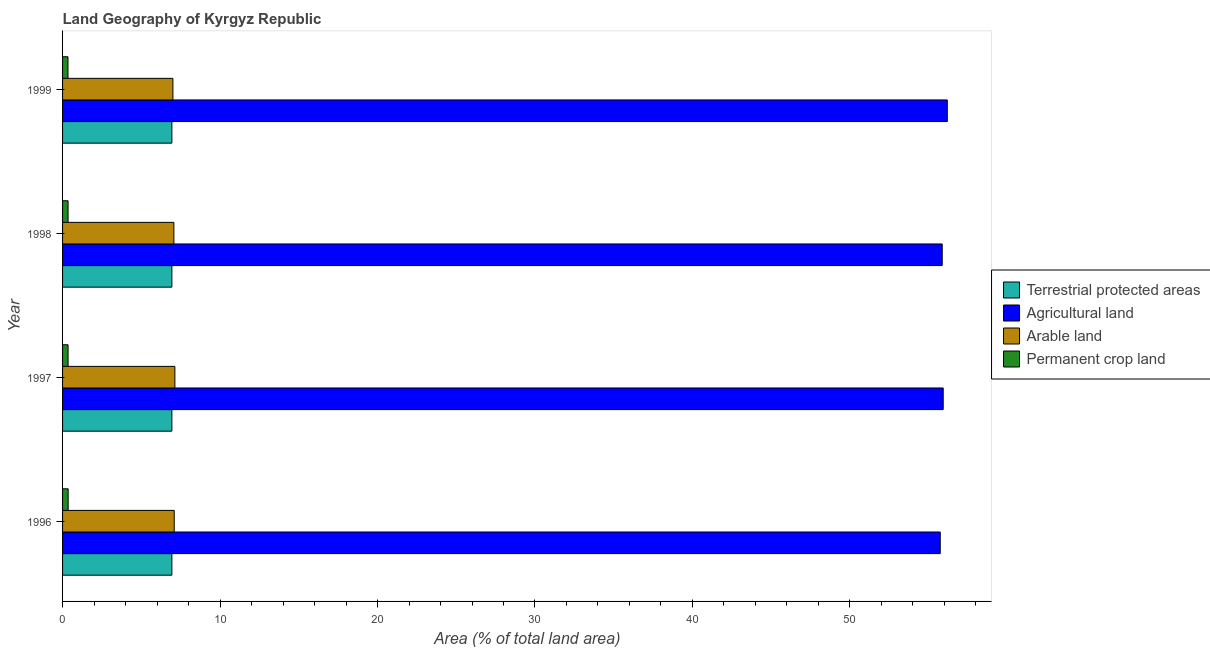Are the number of bars per tick equal to the number of legend labels?
Ensure brevity in your answer.  Yes. How many bars are there on the 4th tick from the bottom?
Give a very brief answer. 4. What is the label of the 1st group of bars from the top?
Your answer should be compact. 1999. What is the percentage of area under arable land in 1999?
Your answer should be compact. 7.01. Across all years, what is the maximum percentage of area under arable land?
Give a very brief answer. 7.13. Across all years, what is the minimum percentage of area under agricultural land?
Provide a short and direct response. 55.74. In which year was the percentage of area under agricultural land minimum?
Make the answer very short. 1996. What is the total percentage of area under permanent crop land in the graph?
Offer a very short reply. 1.4. What is the difference between the percentage of area under agricultural land in 1996 and that in 1997?
Offer a terse response. -0.19. What is the difference between the percentage of area under agricultural land in 1999 and the percentage of area under permanent crop land in 1996?
Your answer should be very brief. 55.83. What is the average percentage of area under permanent crop land per year?
Give a very brief answer. 0.35. In the year 1996, what is the difference between the percentage of area under agricultural land and percentage of area under permanent crop land?
Make the answer very short. 55.38. Is the percentage of land under terrestrial protection in 1996 less than that in 1998?
Give a very brief answer. No. What is the difference between the highest and the second highest percentage of area under arable land?
Provide a short and direct response. 0.04. What is the difference between the highest and the lowest percentage of area under agricultural land?
Offer a very short reply. 0.45. In how many years, is the percentage of area under permanent crop land greater than the average percentage of area under permanent crop land taken over all years?
Keep it short and to the point. 1. Is the sum of the percentage of area under permanent crop land in 1996 and 1997 greater than the maximum percentage of land under terrestrial protection across all years?
Provide a short and direct response. No. What does the 1st bar from the top in 1996 represents?
Your answer should be very brief. Permanent crop land. What does the 2nd bar from the bottom in 1997 represents?
Make the answer very short. Agricultural land. Is it the case that in every year, the sum of the percentage of land under terrestrial protection and percentage of area under agricultural land is greater than the percentage of area under arable land?
Provide a succinct answer. Yes. How many bars are there?
Your answer should be compact. 16. Are all the bars in the graph horizontal?
Provide a short and direct response. Yes. What is the difference between two consecutive major ticks on the X-axis?
Keep it short and to the point. 10. Are the values on the major ticks of X-axis written in scientific E-notation?
Keep it short and to the point. No. Does the graph contain any zero values?
Ensure brevity in your answer.  No. Where does the legend appear in the graph?
Make the answer very short. Center right. How are the legend labels stacked?
Offer a very short reply. Vertical. What is the title of the graph?
Give a very brief answer. Land Geography of Kyrgyz Republic. Does "Secondary schools" appear as one of the legend labels in the graph?
Give a very brief answer. No. What is the label or title of the X-axis?
Keep it short and to the point. Area (% of total land area). What is the label or title of the Y-axis?
Make the answer very short. Year. What is the Area (% of total land area) of Terrestrial protected areas in 1996?
Your answer should be very brief. 6.94. What is the Area (% of total land area) in Agricultural land in 1996?
Your response must be concise. 55.74. What is the Area (% of total land area) of Arable land in 1996?
Offer a terse response. 7.09. What is the Area (% of total land area) in Permanent crop land in 1996?
Your answer should be very brief. 0.35. What is the Area (% of total land area) in Terrestrial protected areas in 1997?
Offer a terse response. 6.94. What is the Area (% of total land area) of Agricultural land in 1997?
Your response must be concise. 55.92. What is the Area (% of total land area) in Arable land in 1997?
Offer a terse response. 7.13. What is the Area (% of total land area) in Permanent crop land in 1997?
Your answer should be compact. 0.35. What is the Area (% of total land area) of Terrestrial protected areas in 1998?
Offer a terse response. 6.94. What is the Area (% of total land area) in Agricultural land in 1998?
Your answer should be very brief. 55.86. What is the Area (% of total land area) in Arable land in 1998?
Your answer should be compact. 7.07. What is the Area (% of total land area) in Permanent crop land in 1998?
Your answer should be very brief. 0.35. What is the Area (% of total land area) in Terrestrial protected areas in 1999?
Provide a short and direct response. 6.94. What is the Area (% of total land area) of Agricultural land in 1999?
Keep it short and to the point. 56.18. What is the Area (% of total land area) in Arable land in 1999?
Ensure brevity in your answer.  7.01. What is the Area (% of total land area) in Permanent crop land in 1999?
Offer a very short reply. 0.34. Across all years, what is the maximum Area (% of total land area) of Terrestrial protected areas?
Provide a short and direct response. 6.94. Across all years, what is the maximum Area (% of total land area) in Agricultural land?
Provide a succinct answer. 56.18. Across all years, what is the maximum Area (% of total land area) in Arable land?
Offer a terse response. 7.13. Across all years, what is the maximum Area (% of total land area) of Permanent crop land?
Offer a very short reply. 0.35. Across all years, what is the minimum Area (% of total land area) in Terrestrial protected areas?
Offer a very short reply. 6.94. Across all years, what is the minimum Area (% of total land area) in Agricultural land?
Make the answer very short. 55.74. Across all years, what is the minimum Area (% of total land area) of Arable land?
Keep it short and to the point. 7.01. Across all years, what is the minimum Area (% of total land area) of Permanent crop land?
Give a very brief answer. 0.34. What is the total Area (% of total land area) in Terrestrial protected areas in the graph?
Your answer should be compact. 27.77. What is the total Area (% of total land area) of Agricultural land in the graph?
Provide a succinct answer. 223.7. What is the total Area (% of total land area) in Arable land in the graph?
Provide a succinct answer. 28.3. What is the total Area (% of total land area) of Permanent crop land in the graph?
Ensure brevity in your answer.  1.4. What is the difference between the Area (% of total land area) of Terrestrial protected areas in 1996 and that in 1997?
Offer a terse response. 0. What is the difference between the Area (% of total land area) in Agricultural land in 1996 and that in 1997?
Provide a succinct answer. -0.19. What is the difference between the Area (% of total land area) in Arable land in 1996 and that in 1997?
Provide a short and direct response. -0.04. What is the difference between the Area (% of total land area) of Permanent crop land in 1996 and that in 1997?
Keep it short and to the point. 0.01. What is the difference between the Area (% of total land area) in Agricultural land in 1996 and that in 1998?
Provide a succinct answer. -0.13. What is the difference between the Area (% of total land area) of Arable land in 1996 and that in 1998?
Your answer should be compact. 0.02. What is the difference between the Area (% of total land area) in Permanent crop land in 1996 and that in 1998?
Give a very brief answer. 0.01. What is the difference between the Area (% of total land area) in Terrestrial protected areas in 1996 and that in 1999?
Your answer should be compact. 0. What is the difference between the Area (% of total land area) in Agricultural land in 1996 and that in 1999?
Make the answer very short. -0.45. What is the difference between the Area (% of total land area) in Arable land in 1996 and that in 1999?
Offer a very short reply. 0.08. What is the difference between the Area (% of total land area) in Permanent crop land in 1996 and that in 1999?
Offer a very short reply. 0.01. What is the difference between the Area (% of total land area) in Agricultural land in 1997 and that in 1998?
Offer a very short reply. 0.06. What is the difference between the Area (% of total land area) in Arable land in 1997 and that in 1998?
Keep it short and to the point. 0.06. What is the difference between the Area (% of total land area) of Permanent crop land in 1997 and that in 1998?
Provide a succinct answer. 0. What is the difference between the Area (% of total land area) in Terrestrial protected areas in 1997 and that in 1999?
Provide a short and direct response. 0. What is the difference between the Area (% of total land area) of Agricultural land in 1997 and that in 1999?
Your response must be concise. -0.26. What is the difference between the Area (% of total land area) in Arable land in 1997 and that in 1999?
Ensure brevity in your answer.  0.13. What is the difference between the Area (% of total land area) in Permanent crop land in 1997 and that in 1999?
Your answer should be very brief. 0.01. What is the difference between the Area (% of total land area) of Agricultural land in 1998 and that in 1999?
Your response must be concise. -0.32. What is the difference between the Area (% of total land area) of Arable land in 1998 and that in 1999?
Provide a succinct answer. 0.06. What is the difference between the Area (% of total land area) in Permanent crop land in 1998 and that in 1999?
Keep it short and to the point. 0.01. What is the difference between the Area (% of total land area) in Terrestrial protected areas in 1996 and the Area (% of total land area) in Agricultural land in 1997?
Keep it short and to the point. -48.98. What is the difference between the Area (% of total land area) of Terrestrial protected areas in 1996 and the Area (% of total land area) of Arable land in 1997?
Your response must be concise. -0.19. What is the difference between the Area (% of total land area) of Terrestrial protected areas in 1996 and the Area (% of total land area) of Permanent crop land in 1997?
Give a very brief answer. 6.59. What is the difference between the Area (% of total land area) in Agricultural land in 1996 and the Area (% of total land area) in Arable land in 1997?
Provide a succinct answer. 48.6. What is the difference between the Area (% of total land area) of Agricultural land in 1996 and the Area (% of total land area) of Permanent crop land in 1997?
Your answer should be compact. 55.39. What is the difference between the Area (% of total land area) in Arable land in 1996 and the Area (% of total land area) in Permanent crop land in 1997?
Offer a terse response. 6.74. What is the difference between the Area (% of total land area) of Terrestrial protected areas in 1996 and the Area (% of total land area) of Agricultural land in 1998?
Offer a very short reply. -48.92. What is the difference between the Area (% of total land area) in Terrestrial protected areas in 1996 and the Area (% of total land area) in Arable land in 1998?
Provide a short and direct response. -0.13. What is the difference between the Area (% of total land area) of Terrestrial protected areas in 1996 and the Area (% of total land area) of Permanent crop land in 1998?
Your response must be concise. 6.59. What is the difference between the Area (% of total land area) in Agricultural land in 1996 and the Area (% of total land area) in Arable land in 1998?
Offer a very short reply. 48.67. What is the difference between the Area (% of total land area) in Agricultural land in 1996 and the Area (% of total land area) in Permanent crop land in 1998?
Keep it short and to the point. 55.39. What is the difference between the Area (% of total land area) in Arable land in 1996 and the Area (% of total land area) in Permanent crop land in 1998?
Your response must be concise. 6.74. What is the difference between the Area (% of total land area) in Terrestrial protected areas in 1996 and the Area (% of total land area) in Agricultural land in 1999?
Make the answer very short. -49.24. What is the difference between the Area (% of total land area) of Terrestrial protected areas in 1996 and the Area (% of total land area) of Arable land in 1999?
Your response must be concise. -0.07. What is the difference between the Area (% of total land area) of Terrestrial protected areas in 1996 and the Area (% of total land area) of Permanent crop land in 1999?
Provide a succinct answer. 6.6. What is the difference between the Area (% of total land area) of Agricultural land in 1996 and the Area (% of total land area) of Arable land in 1999?
Offer a very short reply. 48.73. What is the difference between the Area (% of total land area) in Agricultural land in 1996 and the Area (% of total land area) in Permanent crop land in 1999?
Your answer should be very brief. 55.39. What is the difference between the Area (% of total land area) of Arable land in 1996 and the Area (% of total land area) of Permanent crop land in 1999?
Your answer should be very brief. 6.75. What is the difference between the Area (% of total land area) of Terrestrial protected areas in 1997 and the Area (% of total land area) of Agricultural land in 1998?
Provide a short and direct response. -48.92. What is the difference between the Area (% of total land area) of Terrestrial protected areas in 1997 and the Area (% of total land area) of Arable land in 1998?
Provide a succinct answer. -0.13. What is the difference between the Area (% of total land area) in Terrestrial protected areas in 1997 and the Area (% of total land area) in Permanent crop land in 1998?
Ensure brevity in your answer.  6.59. What is the difference between the Area (% of total land area) in Agricultural land in 1997 and the Area (% of total land area) in Arable land in 1998?
Give a very brief answer. 48.85. What is the difference between the Area (% of total land area) of Agricultural land in 1997 and the Area (% of total land area) of Permanent crop land in 1998?
Provide a short and direct response. 55.57. What is the difference between the Area (% of total land area) of Arable land in 1997 and the Area (% of total land area) of Permanent crop land in 1998?
Your answer should be very brief. 6.78. What is the difference between the Area (% of total land area) of Terrestrial protected areas in 1997 and the Area (% of total land area) of Agricultural land in 1999?
Provide a short and direct response. -49.24. What is the difference between the Area (% of total land area) of Terrestrial protected areas in 1997 and the Area (% of total land area) of Arable land in 1999?
Offer a terse response. -0.07. What is the difference between the Area (% of total land area) of Terrestrial protected areas in 1997 and the Area (% of total land area) of Permanent crop land in 1999?
Your answer should be compact. 6.6. What is the difference between the Area (% of total land area) of Agricultural land in 1997 and the Area (% of total land area) of Arable land in 1999?
Your answer should be compact. 48.92. What is the difference between the Area (% of total land area) of Agricultural land in 1997 and the Area (% of total land area) of Permanent crop land in 1999?
Make the answer very short. 55.58. What is the difference between the Area (% of total land area) of Arable land in 1997 and the Area (% of total land area) of Permanent crop land in 1999?
Make the answer very short. 6.79. What is the difference between the Area (% of total land area) in Terrestrial protected areas in 1998 and the Area (% of total land area) in Agricultural land in 1999?
Provide a short and direct response. -49.24. What is the difference between the Area (% of total land area) of Terrestrial protected areas in 1998 and the Area (% of total land area) of Arable land in 1999?
Your response must be concise. -0.07. What is the difference between the Area (% of total land area) in Terrestrial protected areas in 1998 and the Area (% of total land area) in Permanent crop land in 1999?
Your response must be concise. 6.6. What is the difference between the Area (% of total land area) of Agricultural land in 1998 and the Area (% of total land area) of Arable land in 1999?
Your response must be concise. 48.85. What is the difference between the Area (% of total land area) in Agricultural land in 1998 and the Area (% of total land area) in Permanent crop land in 1999?
Offer a very short reply. 55.52. What is the difference between the Area (% of total land area) in Arable land in 1998 and the Area (% of total land area) in Permanent crop land in 1999?
Provide a succinct answer. 6.73. What is the average Area (% of total land area) of Terrestrial protected areas per year?
Provide a short and direct response. 6.94. What is the average Area (% of total land area) of Agricultural land per year?
Make the answer very short. 55.93. What is the average Area (% of total land area) of Arable land per year?
Ensure brevity in your answer.  7.08. What is the average Area (% of total land area) of Permanent crop land per year?
Make the answer very short. 0.35. In the year 1996, what is the difference between the Area (% of total land area) of Terrestrial protected areas and Area (% of total land area) of Agricultural land?
Your response must be concise. -48.79. In the year 1996, what is the difference between the Area (% of total land area) in Terrestrial protected areas and Area (% of total land area) in Arable land?
Keep it short and to the point. -0.15. In the year 1996, what is the difference between the Area (% of total land area) of Terrestrial protected areas and Area (% of total land area) of Permanent crop land?
Your answer should be compact. 6.59. In the year 1996, what is the difference between the Area (% of total land area) in Agricultural land and Area (% of total land area) in Arable land?
Offer a terse response. 48.64. In the year 1996, what is the difference between the Area (% of total land area) of Agricultural land and Area (% of total land area) of Permanent crop land?
Your answer should be compact. 55.38. In the year 1996, what is the difference between the Area (% of total land area) of Arable land and Area (% of total land area) of Permanent crop land?
Give a very brief answer. 6.74. In the year 1997, what is the difference between the Area (% of total land area) in Terrestrial protected areas and Area (% of total land area) in Agricultural land?
Your response must be concise. -48.98. In the year 1997, what is the difference between the Area (% of total land area) of Terrestrial protected areas and Area (% of total land area) of Arable land?
Provide a succinct answer. -0.19. In the year 1997, what is the difference between the Area (% of total land area) of Terrestrial protected areas and Area (% of total land area) of Permanent crop land?
Provide a short and direct response. 6.59. In the year 1997, what is the difference between the Area (% of total land area) in Agricultural land and Area (% of total land area) in Arable land?
Your answer should be compact. 48.79. In the year 1997, what is the difference between the Area (% of total land area) of Agricultural land and Area (% of total land area) of Permanent crop land?
Your answer should be compact. 55.57. In the year 1997, what is the difference between the Area (% of total land area) of Arable land and Area (% of total land area) of Permanent crop land?
Keep it short and to the point. 6.78. In the year 1998, what is the difference between the Area (% of total land area) in Terrestrial protected areas and Area (% of total land area) in Agricultural land?
Provide a succinct answer. -48.92. In the year 1998, what is the difference between the Area (% of total land area) in Terrestrial protected areas and Area (% of total land area) in Arable land?
Offer a terse response. -0.13. In the year 1998, what is the difference between the Area (% of total land area) in Terrestrial protected areas and Area (% of total land area) in Permanent crop land?
Make the answer very short. 6.59. In the year 1998, what is the difference between the Area (% of total land area) of Agricultural land and Area (% of total land area) of Arable land?
Ensure brevity in your answer.  48.79. In the year 1998, what is the difference between the Area (% of total land area) of Agricultural land and Area (% of total land area) of Permanent crop land?
Your response must be concise. 55.51. In the year 1998, what is the difference between the Area (% of total land area) of Arable land and Area (% of total land area) of Permanent crop land?
Your answer should be very brief. 6.72. In the year 1999, what is the difference between the Area (% of total land area) of Terrestrial protected areas and Area (% of total land area) of Agricultural land?
Ensure brevity in your answer.  -49.24. In the year 1999, what is the difference between the Area (% of total land area) of Terrestrial protected areas and Area (% of total land area) of Arable land?
Make the answer very short. -0.07. In the year 1999, what is the difference between the Area (% of total land area) of Terrestrial protected areas and Area (% of total land area) of Permanent crop land?
Offer a terse response. 6.6. In the year 1999, what is the difference between the Area (% of total land area) in Agricultural land and Area (% of total land area) in Arable land?
Ensure brevity in your answer.  49.18. In the year 1999, what is the difference between the Area (% of total land area) in Agricultural land and Area (% of total land area) in Permanent crop land?
Your answer should be very brief. 55.84. In the year 1999, what is the difference between the Area (% of total land area) in Arable land and Area (% of total land area) in Permanent crop land?
Make the answer very short. 6.66. What is the ratio of the Area (% of total land area) of Terrestrial protected areas in 1996 to that in 1997?
Offer a terse response. 1. What is the ratio of the Area (% of total land area) of Arable land in 1996 to that in 1997?
Ensure brevity in your answer.  0.99. What is the ratio of the Area (% of total land area) in Permanent crop land in 1996 to that in 1997?
Offer a terse response. 1.01. What is the ratio of the Area (% of total land area) of Terrestrial protected areas in 1996 to that in 1998?
Your answer should be very brief. 1. What is the ratio of the Area (% of total land area) in Agricultural land in 1996 to that in 1998?
Keep it short and to the point. 1. What is the ratio of the Area (% of total land area) in Permanent crop land in 1996 to that in 1998?
Your answer should be very brief. 1.01. What is the ratio of the Area (% of total land area) in Agricultural land in 1996 to that in 1999?
Ensure brevity in your answer.  0.99. What is the ratio of the Area (% of total land area) in Arable land in 1996 to that in 1999?
Give a very brief answer. 1.01. What is the ratio of the Area (% of total land area) of Permanent crop land in 1996 to that in 1999?
Ensure brevity in your answer.  1.03. What is the ratio of the Area (% of total land area) in Terrestrial protected areas in 1997 to that in 1998?
Provide a short and direct response. 1. What is the ratio of the Area (% of total land area) in Agricultural land in 1997 to that in 1998?
Your answer should be very brief. 1. What is the ratio of the Area (% of total land area) in Arable land in 1997 to that in 1998?
Ensure brevity in your answer.  1.01. What is the ratio of the Area (% of total land area) in Permanent crop land in 1997 to that in 1998?
Ensure brevity in your answer.  1. What is the ratio of the Area (% of total land area) of Terrestrial protected areas in 1997 to that in 1999?
Provide a short and direct response. 1. What is the ratio of the Area (% of total land area) in Agricultural land in 1997 to that in 1999?
Keep it short and to the point. 1. What is the ratio of the Area (% of total land area) of Arable land in 1997 to that in 1999?
Ensure brevity in your answer.  1.02. What is the ratio of the Area (% of total land area) in Permanent crop land in 1997 to that in 1999?
Provide a short and direct response. 1.02. What is the ratio of the Area (% of total land area) of Terrestrial protected areas in 1998 to that in 1999?
Provide a succinct answer. 1. What is the ratio of the Area (% of total land area) of Agricultural land in 1998 to that in 1999?
Keep it short and to the point. 0.99. What is the ratio of the Area (% of total land area) in Arable land in 1998 to that in 1999?
Your answer should be compact. 1.01. What is the ratio of the Area (% of total land area) of Permanent crop land in 1998 to that in 1999?
Keep it short and to the point. 1.02. What is the difference between the highest and the second highest Area (% of total land area) of Agricultural land?
Make the answer very short. 0.26. What is the difference between the highest and the second highest Area (% of total land area) of Arable land?
Your answer should be very brief. 0.04. What is the difference between the highest and the second highest Area (% of total land area) of Permanent crop land?
Provide a short and direct response. 0.01. What is the difference between the highest and the lowest Area (% of total land area) in Terrestrial protected areas?
Provide a short and direct response. 0. What is the difference between the highest and the lowest Area (% of total land area) of Agricultural land?
Give a very brief answer. 0.45. What is the difference between the highest and the lowest Area (% of total land area) in Arable land?
Your answer should be compact. 0.13. What is the difference between the highest and the lowest Area (% of total land area) in Permanent crop land?
Your response must be concise. 0.01. 